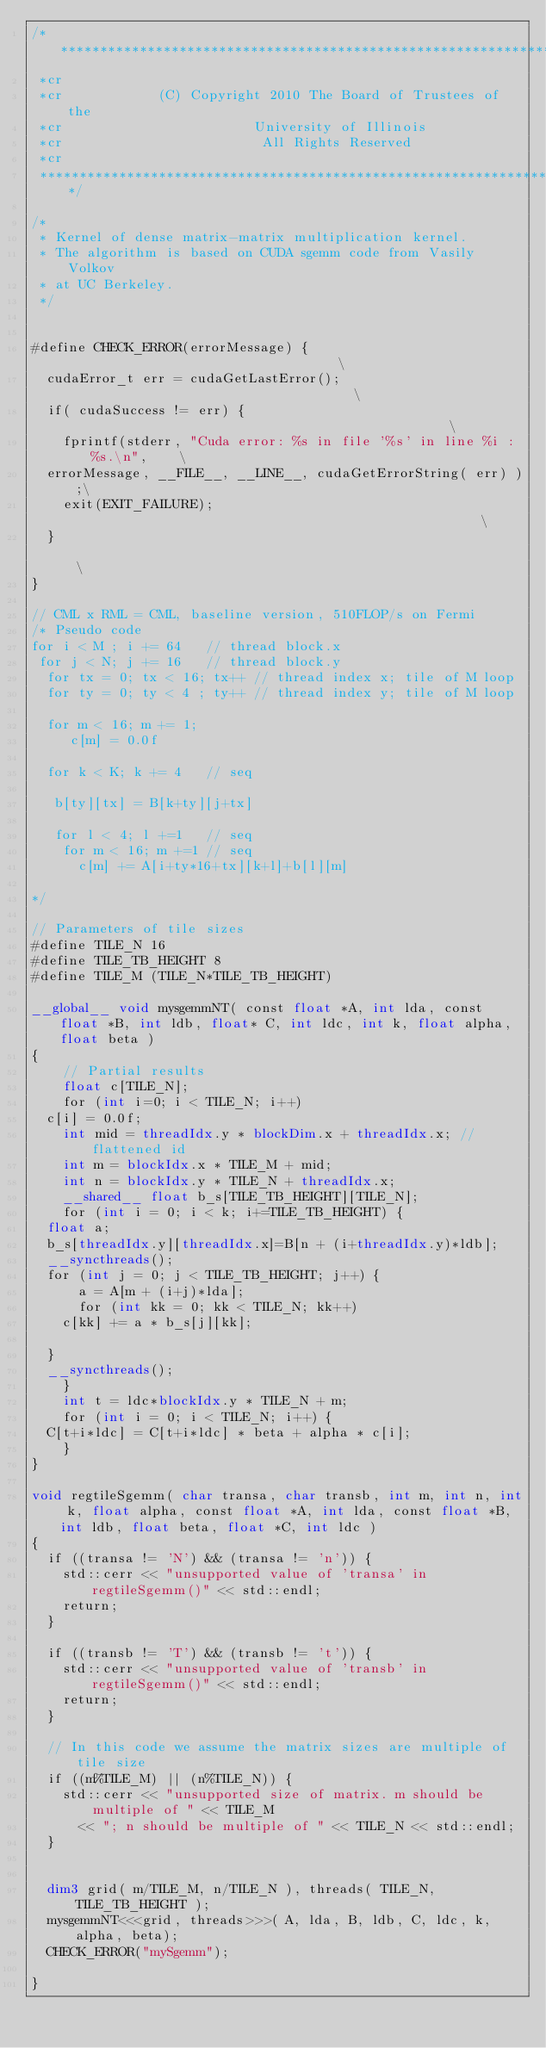<code> <loc_0><loc_0><loc_500><loc_500><_Cuda_>/***************************************************************************
 *cr
 *cr            (C) Copyright 2010 The Board of Trustees of the
 *cr                        University of Illinois
 *cr                         All Rights Reserved
 *cr
 ***************************************************************************/

/* 
 * Kernel of dense matrix-matrix multiplication kernel.
 * The algorithm is based on CUDA sgemm code from Vasily Volkov
 * at UC Berkeley.
 */


#define CHECK_ERROR(errorMessage) {                                    \
  cudaError_t err = cudaGetLastError();                                    \
  if( cudaSuccess != err) {                                                \
    fprintf(stderr, "Cuda error: %s in file '%s' in line %i : %s.\n",    \
	errorMessage, __FILE__, __LINE__, cudaGetErrorString( err) );\
    exit(EXIT_FAILURE);                                                  \
  }                                                                        \
}

// CML x RML = CML, baseline version, 510FLOP/s on Fermi
/* Pseudo code
for i < M ; i += 64   // thread block.x
 for j < N; j += 16   // thread block.y
  for tx = 0; tx < 16; tx++ // thread index x; tile of M loop
  for ty = 0; ty < 4 ; ty++ // thread index y; tile of M loop

  for m < 16; m += 1;
     c[m] = 0.0f

  for k < K; k += 4   // seq

   b[ty][tx] = B[k+ty][j+tx]

   for l < 4; l +=1   // seq
    for m < 16; m +=1 // seq
      c[m] += A[i+ty*16+tx][k+l]+b[l][m]

*/

// Parameters of tile sizes
#define TILE_N 16 
#define TILE_TB_HEIGHT 8
#define TILE_M (TILE_N*TILE_TB_HEIGHT)

__global__ void mysgemmNT( const float *A, int lda, const float *B, int ldb, float* C, int ldc, int k, float alpha, float beta )
{
    // Partial results 
    float c[TILE_N];
    for (int i=0; i < TILE_N; i++)
	c[i] = 0.0f;
    int mid = threadIdx.y * blockDim.x + threadIdx.x; //flattened id
    int m = blockIdx.x * TILE_M + mid;
    int n = blockIdx.y * TILE_N + threadIdx.x;
    __shared__ float b_s[TILE_TB_HEIGHT][TILE_N];
    for (int i = 0; i < k; i+=TILE_TB_HEIGHT) {
	float a; 
	b_s[threadIdx.y][threadIdx.x]=B[n + (i+threadIdx.y)*ldb];
	__syncthreads();
	for (int j = 0; j < TILE_TB_HEIGHT; j++) {
	    a = A[m + (i+j)*lda];
	    for (int kk = 0; kk < TILE_N; kk++)
		c[kk] += a * b_s[j][kk];

	}
	__syncthreads();
    }
    int t = ldc*blockIdx.y * TILE_N + m;
    for (int i = 0; i < TILE_N; i++) {
	C[t+i*ldc] = C[t+i*ldc] * beta + alpha * c[i];
    }
}

void regtileSgemm( char transa, char transb, int m, int n, int k, float alpha, const float *A, int lda, const float *B, int ldb, float beta, float *C, int ldc )
{
  if ((transa != 'N') && (transa != 'n')) {
    std::cerr << "unsupported value of 'transa' in regtileSgemm()" << std::endl;
    return;
  }
  
  if ((transb != 'T') && (transb != 't')) {
    std::cerr << "unsupported value of 'transb' in regtileSgemm()" << std::endl;
    return;
  }
  
  // In this code we assume the matrix sizes are multiple of tile size
  if ((m%TILE_M) || (n%TILE_N)) {
    std::cerr << "unsupported size of matrix. m should be multiple of " << TILE_M
      << "; n should be multiple of " << TILE_N << std::endl;
  }


  dim3 grid( m/TILE_M, n/TILE_N ), threads( TILE_N, TILE_TB_HEIGHT );
  mysgemmNT<<<grid, threads>>>( A, lda, B, ldb, C, ldc, k, alpha, beta);
  CHECK_ERROR("mySgemm");

}

</code> 